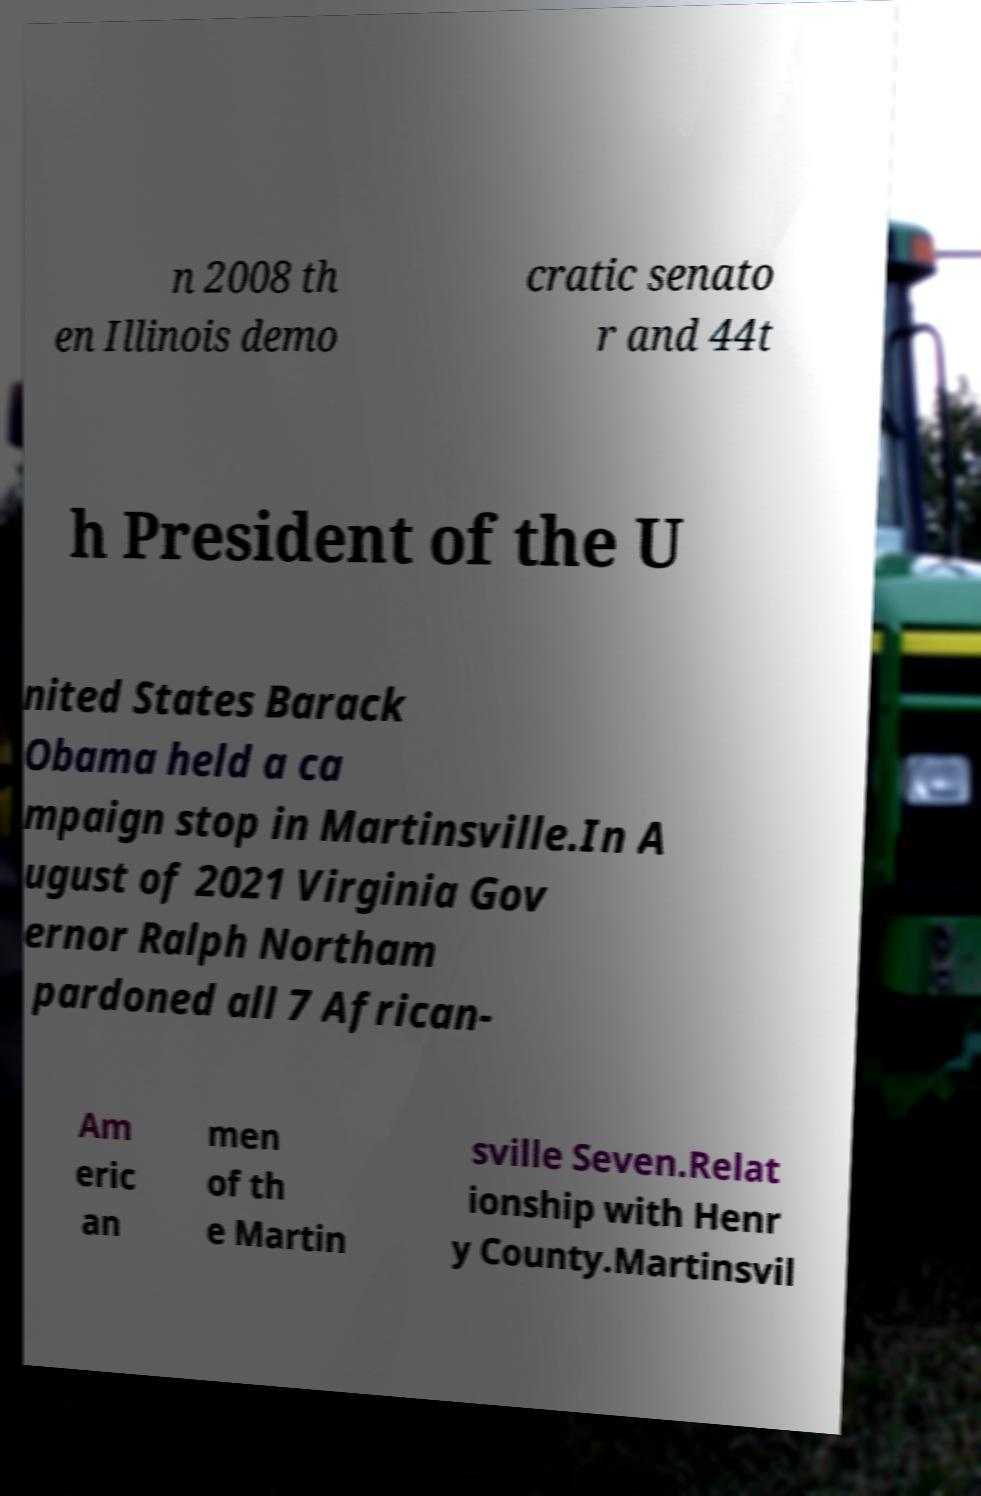There's text embedded in this image that I need extracted. Can you transcribe it verbatim? n 2008 th en Illinois demo cratic senato r and 44t h President of the U nited States Barack Obama held a ca mpaign stop in Martinsville.In A ugust of 2021 Virginia Gov ernor Ralph Northam pardoned all 7 African- Am eric an men of th e Martin sville Seven.Relat ionship with Henr y County.Martinsvil 